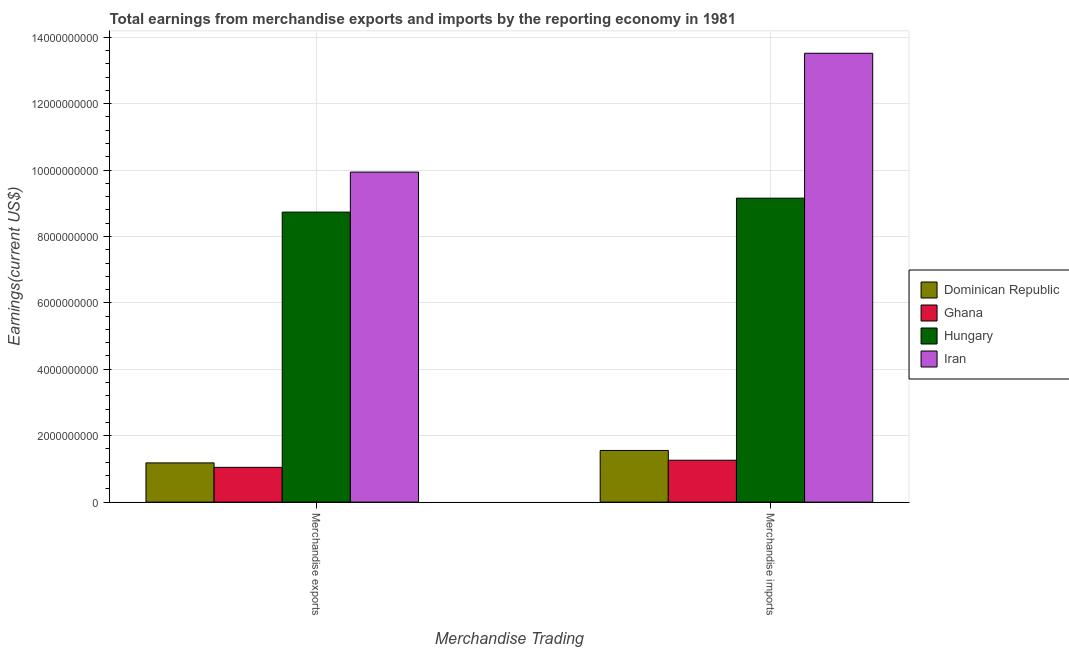How many different coloured bars are there?
Your response must be concise. 4. How many bars are there on the 1st tick from the left?
Provide a succinct answer. 4. How many bars are there on the 1st tick from the right?
Make the answer very short. 4. What is the label of the 2nd group of bars from the left?
Ensure brevity in your answer.  Merchandise imports. What is the earnings from merchandise imports in Iran?
Your answer should be very brief. 1.35e+1. Across all countries, what is the maximum earnings from merchandise exports?
Offer a terse response. 9.94e+09. Across all countries, what is the minimum earnings from merchandise imports?
Give a very brief answer. 1.26e+09. In which country was the earnings from merchandise exports maximum?
Your answer should be compact. Iran. In which country was the earnings from merchandise exports minimum?
Provide a short and direct response. Ghana. What is the total earnings from merchandise imports in the graph?
Your response must be concise. 2.55e+1. What is the difference between the earnings from merchandise imports in Hungary and that in Ghana?
Offer a very short reply. 7.89e+09. What is the difference between the earnings from merchandise exports in Ghana and the earnings from merchandise imports in Hungary?
Give a very brief answer. -8.11e+09. What is the average earnings from merchandise exports per country?
Ensure brevity in your answer.  5.22e+09. What is the difference between the earnings from merchandise imports and earnings from merchandise exports in Ghana?
Ensure brevity in your answer.  2.15e+08. What is the ratio of the earnings from merchandise imports in Hungary to that in Iran?
Provide a short and direct response. 0.68. In how many countries, is the earnings from merchandise imports greater than the average earnings from merchandise imports taken over all countries?
Provide a short and direct response. 2. What does the 4th bar from the left in Merchandise imports represents?
Keep it short and to the point. Iran. What does the 1st bar from the right in Merchandise exports represents?
Your answer should be compact. Iran. How many bars are there?
Give a very brief answer. 8. Are the values on the major ticks of Y-axis written in scientific E-notation?
Your answer should be very brief. No. Does the graph contain grids?
Offer a very short reply. Yes. Where does the legend appear in the graph?
Offer a terse response. Center right. How many legend labels are there?
Provide a succinct answer. 4. How are the legend labels stacked?
Provide a succinct answer. Vertical. What is the title of the graph?
Offer a terse response. Total earnings from merchandise exports and imports by the reporting economy in 1981. What is the label or title of the X-axis?
Offer a terse response. Merchandise Trading. What is the label or title of the Y-axis?
Ensure brevity in your answer.  Earnings(current US$). What is the Earnings(current US$) of Dominican Republic in Merchandise exports?
Provide a short and direct response. 1.18e+09. What is the Earnings(current US$) in Ghana in Merchandise exports?
Keep it short and to the point. 1.05e+09. What is the Earnings(current US$) in Hungary in Merchandise exports?
Your response must be concise. 8.73e+09. What is the Earnings(current US$) of Iran in Merchandise exports?
Keep it short and to the point. 9.94e+09. What is the Earnings(current US$) in Dominican Republic in Merchandise imports?
Offer a terse response. 1.56e+09. What is the Earnings(current US$) of Ghana in Merchandise imports?
Ensure brevity in your answer.  1.26e+09. What is the Earnings(current US$) of Hungary in Merchandise imports?
Your response must be concise. 9.15e+09. What is the Earnings(current US$) in Iran in Merchandise imports?
Make the answer very short. 1.35e+1. Across all Merchandise Trading, what is the maximum Earnings(current US$) of Dominican Republic?
Your answer should be compact. 1.56e+09. Across all Merchandise Trading, what is the maximum Earnings(current US$) in Ghana?
Keep it short and to the point. 1.26e+09. Across all Merchandise Trading, what is the maximum Earnings(current US$) in Hungary?
Offer a terse response. 9.15e+09. Across all Merchandise Trading, what is the maximum Earnings(current US$) in Iran?
Keep it short and to the point. 1.35e+1. Across all Merchandise Trading, what is the minimum Earnings(current US$) in Dominican Republic?
Give a very brief answer. 1.18e+09. Across all Merchandise Trading, what is the minimum Earnings(current US$) of Ghana?
Give a very brief answer. 1.05e+09. Across all Merchandise Trading, what is the minimum Earnings(current US$) in Hungary?
Keep it short and to the point. 8.73e+09. Across all Merchandise Trading, what is the minimum Earnings(current US$) in Iran?
Your response must be concise. 9.94e+09. What is the total Earnings(current US$) of Dominican Republic in the graph?
Your answer should be very brief. 2.74e+09. What is the total Earnings(current US$) of Ghana in the graph?
Provide a succinct answer. 2.31e+09. What is the total Earnings(current US$) in Hungary in the graph?
Offer a terse response. 1.79e+1. What is the total Earnings(current US$) in Iran in the graph?
Offer a terse response. 2.35e+1. What is the difference between the Earnings(current US$) in Dominican Republic in Merchandise exports and that in Merchandise imports?
Ensure brevity in your answer.  -3.75e+08. What is the difference between the Earnings(current US$) in Ghana in Merchandise exports and that in Merchandise imports?
Your response must be concise. -2.15e+08. What is the difference between the Earnings(current US$) in Hungary in Merchandise exports and that in Merchandise imports?
Offer a terse response. -4.20e+08. What is the difference between the Earnings(current US$) of Iran in Merchandise exports and that in Merchandise imports?
Your response must be concise. -3.58e+09. What is the difference between the Earnings(current US$) of Dominican Republic in Merchandise exports and the Earnings(current US$) of Ghana in Merchandise imports?
Your response must be concise. -8.03e+07. What is the difference between the Earnings(current US$) in Dominican Republic in Merchandise exports and the Earnings(current US$) in Hungary in Merchandise imports?
Your response must be concise. -7.97e+09. What is the difference between the Earnings(current US$) of Dominican Republic in Merchandise exports and the Earnings(current US$) of Iran in Merchandise imports?
Give a very brief answer. -1.23e+1. What is the difference between the Earnings(current US$) in Ghana in Merchandise exports and the Earnings(current US$) in Hungary in Merchandise imports?
Your response must be concise. -8.11e+09. What is the difference between the Earnings(current US$) in Ghana in Merchandise exports and the Earnings(current US$) in Iran in Merchandise imports?
Offer a terse response. -1.25e+1. What is the difference between the Earnings(current US$) in Hungary in Merchandise exports and the Earnings(current US$) in Iran in Merchandise imports?
Offer a terse response. -4.78e+09. What is the average Earnings(current US$) of Dominican Republic per Merchandise Trading?
Provide a succinct answer. 1.37e+09. What is the average Earnings(current US$) of Ghana per Merchandise Trading?
Give a very brief answer. 1.15e+09. What is the average Earnings(current US$) in Hungary per Merchandise Trading?
Ensure brevity in your answer.  8.94e+09. What is the average Earnings(current US$) of Iran per Merchandise Trading?
Offer a terse response. 1.17e+1. What is the difference between the Earnings(current US$) of Dominican Republic and Earnings(current US$) of Ghana in Merchandise exports?
Your answer should be very brief. 1.35e+08. What is the difference between the Earnings(current US$) in Dominican Republic and Earnings(current US$) in Hungary in Merchandise exports?
Give a very brief answer. -7.55e+09. What is the difference between the Earnings(current US$) of Dominican Republic and Earnings(current US$) of Iran in Merchandise exports?
Provide a short and direct response. -8.76e+09. What is the difference between the Earnings(current US$) in Ghana and Earnings(current US$) in Hungary in Merchandise exports?
Your response must be concise. -7.69e+09. What is the difference between the Earnings(current US$) of Ghana and Earnings(current US$) of Iran in Merchandise exports?
Provide a succinct answer. -8.89e+09. What is the difference between the Earnings(current US$) in Hungary and Earnings(current US$) in Iran in Merchandise exports?
Offer a very short reply. -1.20e+09. What is the difference between the Earnings(current US$) of Dominican Republic and Earnings(current US$) of Ghana in Merchandise imports?
Provide a succinct answer. 2.95e+08. What is the difference between the Earnings(current US$) of Dominican Republic and Earnings(current US$) of Hungary in Merchandise imports?
Ensure brevity in your answer.  -7.60e+09. What is the difference between the Earnings(current US$) of Dominican Republic and Earnings(current US$) of Iran in Merchandise imports?
Keep it short and to the point. -1.20e+1. What is the difference between the Earnings(current US$) of Ghana and Earnings(current US$) of Hungary in Merchandise imports?
Provide a succinct answer. -7.89e+09. What is the difference between the Earnings(current US$) in Ghana and Earnings(current US$) in Iran in Merchandise imports?
Your response must be concise. -1.23e+1. What is the difference between the Earnings(current US$) in Hungary and Earnings(current US$) in Iran in Merchandise imports?
Your answer should be compact. -4.36e+09. What is the ratio of the Earnings(current US$) in Dominican Republic in Merchandise exports to that in Merchandise imports?
Give a very brief answer. 0.76. What is the ratio of the Earnings(current US$) in Ghana in Merchandise exports to that in Merchandise imports?
Offer a very short reply. 0.83. What is the ratio of the Earnings(current US$) of Hungary in Merchandise exports to that in Merchandise imports?
Keep it short and to the point. 0.95. What is the ratio of the Earnings(current US$) in Iran in Merchandise exports to that in Merchandise imports?
Give a very brief answer. 0.74. What is the difference between the highest and the second highest Earnings(current US$) of Dominican Republic?
Keep it short and to the point. 3.75e+08. What is the difference between the highest and the second highest Earnings(current US$) of Ghana?
Offer a terse response. 2.15e+08. What is the difference between the highest and the second highest Earnings(current US$) in Hungary?
Give a very brief answer. 4.20e+08. What is the difference between the highest and the second highest Earnings(current US$) in Iran?
Your response must be concise. 3.58e+09. What is the difference between the highest and the lowest Earnings(current US$) of Dominican Republic?
Offer a terse response. 3.75e+08. What is the difference between the highest and the lowest Earnings(current US$) in Ghana?
Provide a succinct answer. 2.15e+08. What is the difference between the highest and the lowest Earnings(current US$) of Hungary?
Give a very brief answer. 4.20e+08. What is the difference between the highest and the lowest Earnings(current US$) of Iran?
Provide a short and direct response. 3.58e+09. 